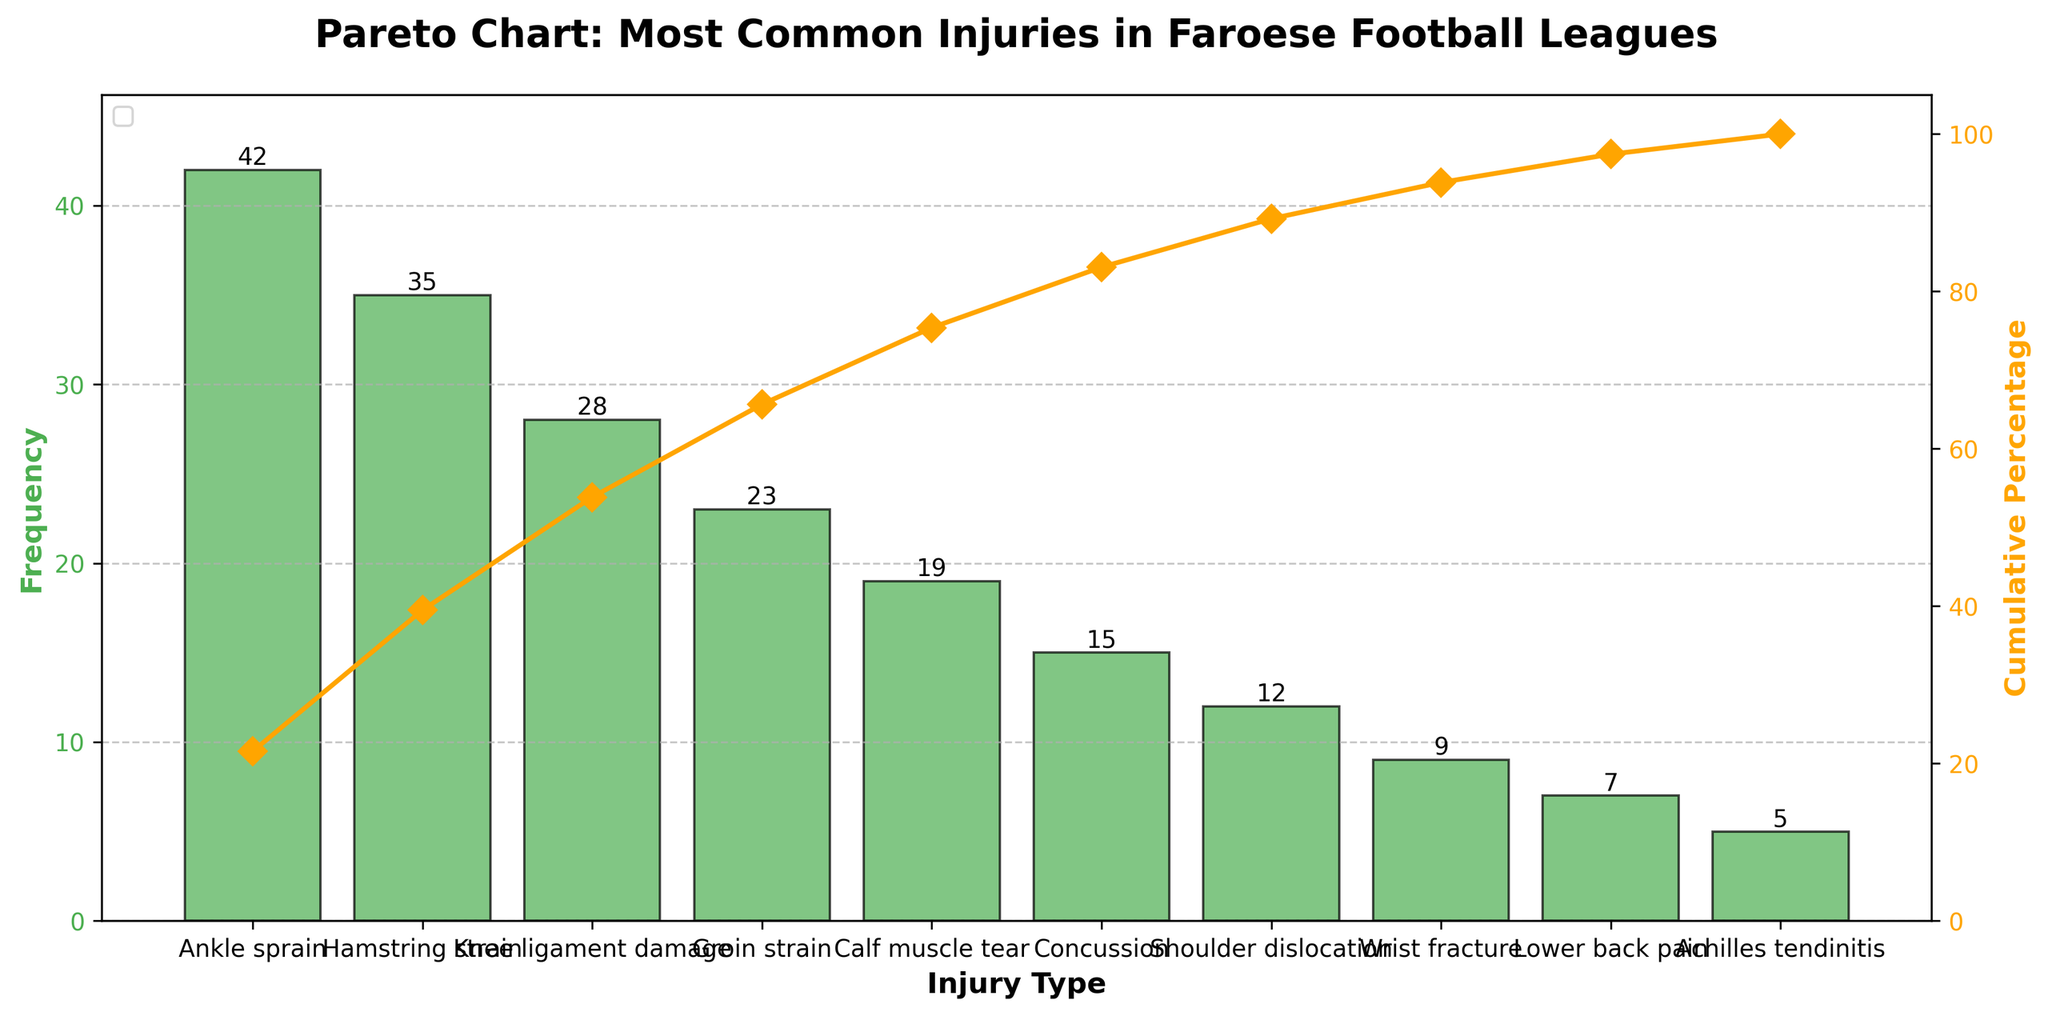What is the most common injury in the Faroese football leagues? The most common injury is represented by the tallest bar in the bar chart, which corresponds to the first injury listed due to the descending order of frequency.
Answer: Ankle sprain What is the frequency of shoulder dislocations? Locate the "Shoulder dislocation" bar on the x-axis and read the height of the bar.
Answer: 12 Which injury has the lowest frequency and what is its value? The injury with the lowest frequency is represented by the shortest bar and is the last on the list in the descending order.
Answer: Achilles tendinitis with a frequency of 5 How many injuries have a frequency greater than 20? Count the bars with heights greater than 20.
Answer: 4 (Ankle sprain, Hamstring strain, Knee ligament damage, Groin strain) What is the cumulative percentage of the top three most common injuries? Sum the frequencies of the top three injuries and divide by the total, then multiply by 100. The top three are Ankle sprain (42), Hamstring strain (35), and Knee ligament damage (28). Total is 42 + 35 + 28 = 105. 105/195 * 100 ≈ 53.85%.
Answer: 53.85% Between calf muscle tear and concussion, which has the higher frequency? Compare the heights of the "Calf muscle tear" and "Concussion" bars.
Answer: Calf muscle tear (19 vs. 15) What injury type causes 7 occurrences? Look for the bar on the x-axis where the height corresponds to 7.
Answer: Lower back pain What cumulative percentage is indicated at the ankle sprain's frequency? Track the cumulative percentage line directly above the top of the "Ankle sprain" bar.
Answer: 21.53% How many injuries contribute to the first 80% of cumulative frequency? Add the cumulative percentages until they surpass 80%. Ankle sprain (21.53), Hamstring strain (39.74), Knee ligament damage (54.10), Groin strain (65.90), Calf muscle tear (75.38), and Concussion (83.08). The sixth injury, Concussion, takes the cumulative percentage past 80%.
Answer: 6 injuries (Ankle sprain through Concussion) 